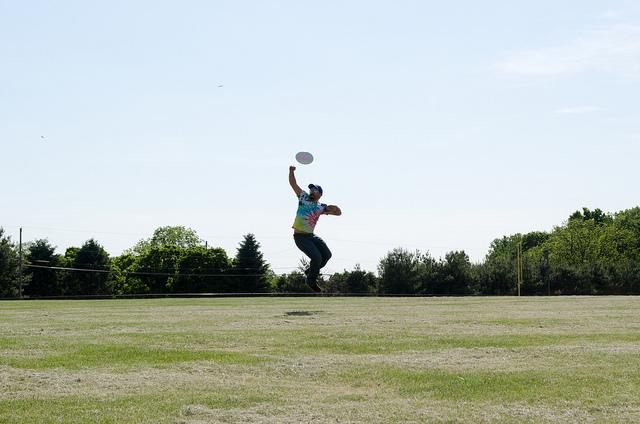How many people are in the image?
Concise answer only. 1. Is the man going to catch it?
Be succinct. Yes. What is the child doing?
Quick response, please. Frisbee. What is the person reaching for?
Answer briefly. Frisbee. What color is the man's shirt?
Short answer required. Multicolored. What color is the Frisbee?
Write a very short answer. White. 